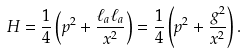<formula> <loc_0><loc_0><loc_500><loc_500>H = \frac { 1 } { 4 } \left ( p ^ { 2 } + \frac { \ell _ { a } \ell _ { a } } { x ^ { 2 } } \right ) = \frac { 1 } { 4 } \left ( p ^ { 2 } + \frac { g ^ { 2 } } { x ^ { 2 } } \right ) .</formula> 